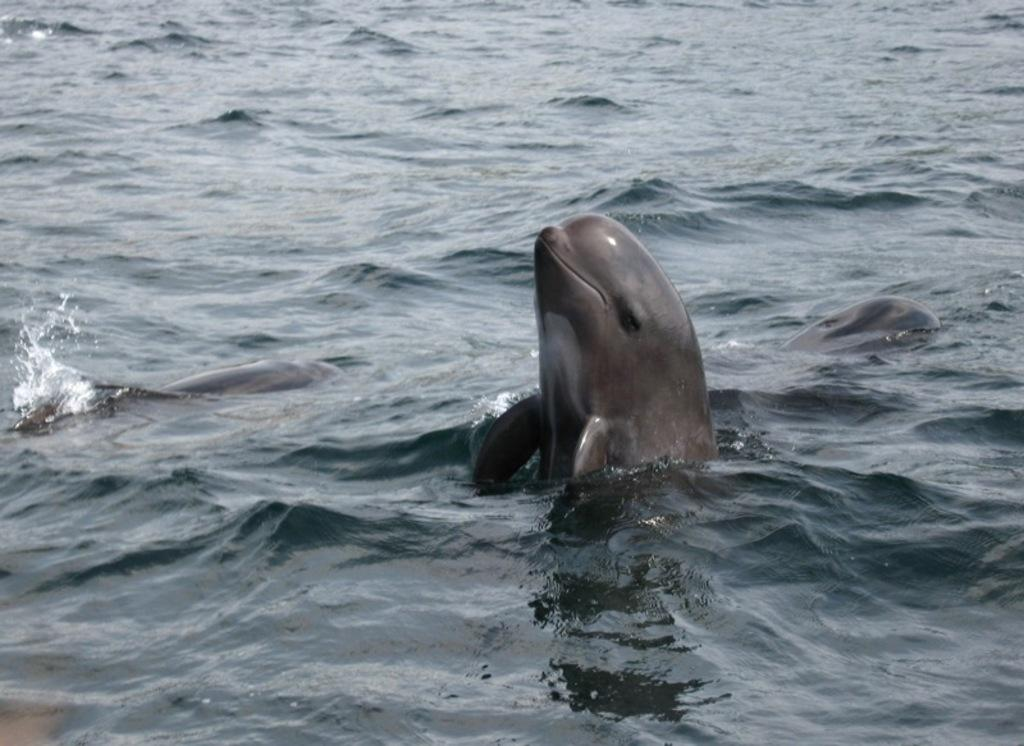What is visible in the image? Water is visible in the image. What type of animal can be seen in the water? There is a black color whale in the water. What type of coal can be seen in the image? There is no coal present in the image. What type of cherry is being used as a decoration in the image? There is no cherry present in the image. 